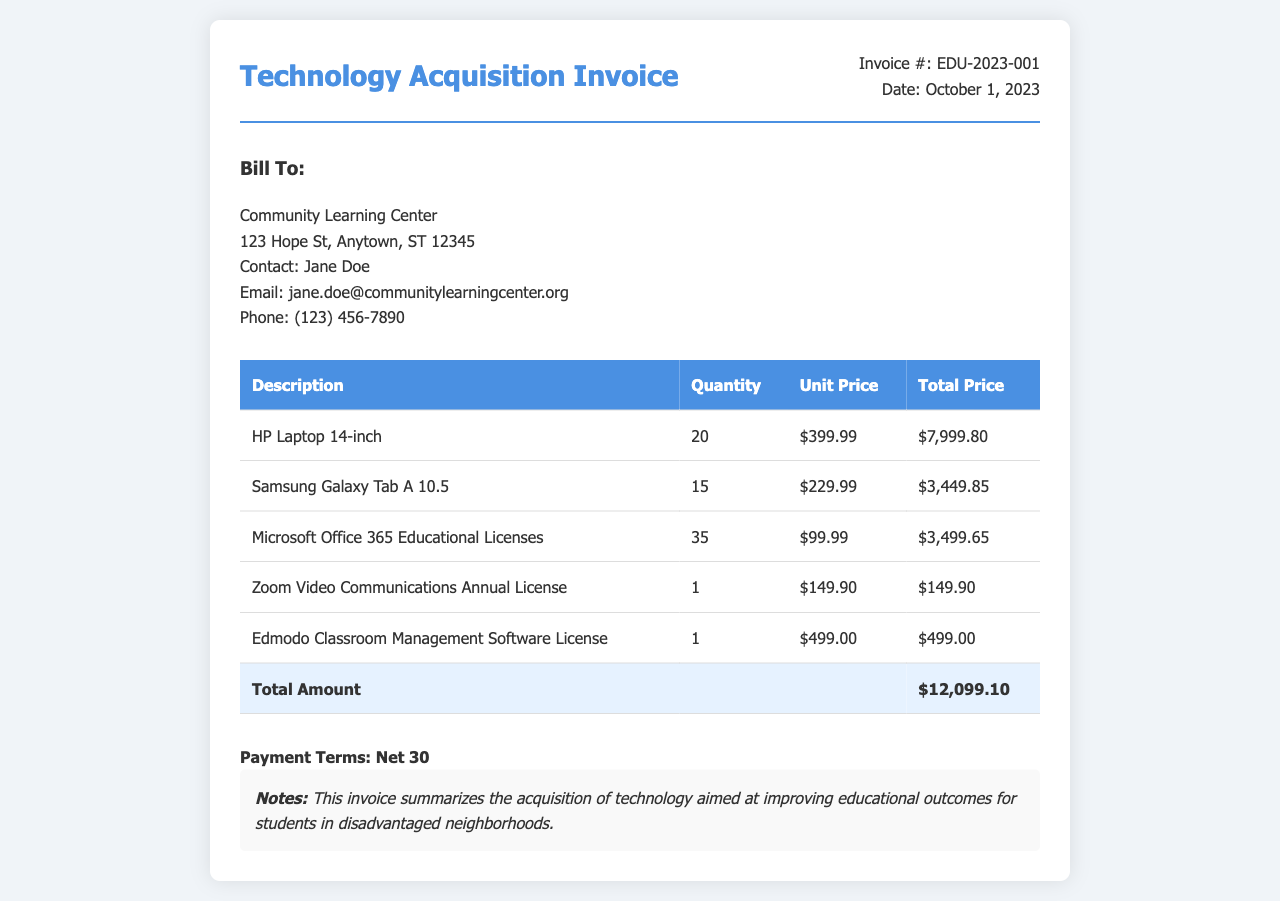What is the invoice number? The invoice number is specified in the document and is EDU-2023-001.
Answer: EDU-2023-001 What is the date of the invoice? The date is provided in the invoice details, indicating when it was issued.
Answer: October 1, 2023 Who is the contact person at the billing address? This information is found in the "Bill To" section, indicating who to reach out to for the invoice.
Answer: Jane Doe How many HP Laptops were purchased? The quantity of HP Laptops is stated under the description section of the itemized purchases.
Answer: 20 What is the total amount of the invoice? The total amount is a summary of all the itemized costs provided in the table.
Answer: $12,099.10 What type of software licenses were included in the purchase? The document lists various software, providing insights into the licenses acquired.
Answer: Microsoft Office 365 Educational Licenses, Zoom Video Communications Annual License, Edmodo Classroom Management Software License What is the payment term specified in the invoice? This information outlines the conditions for payment after receiving the invoice.
Answer: Net 30 What is one of the notes mentioned in the invoice? The notes section provides additional context or information about the purpose of the invoice.
Answer: This invoice summarizes the acquisition of technology aimed at improving educational outcomes for students in disadvantaged neighborhoods 